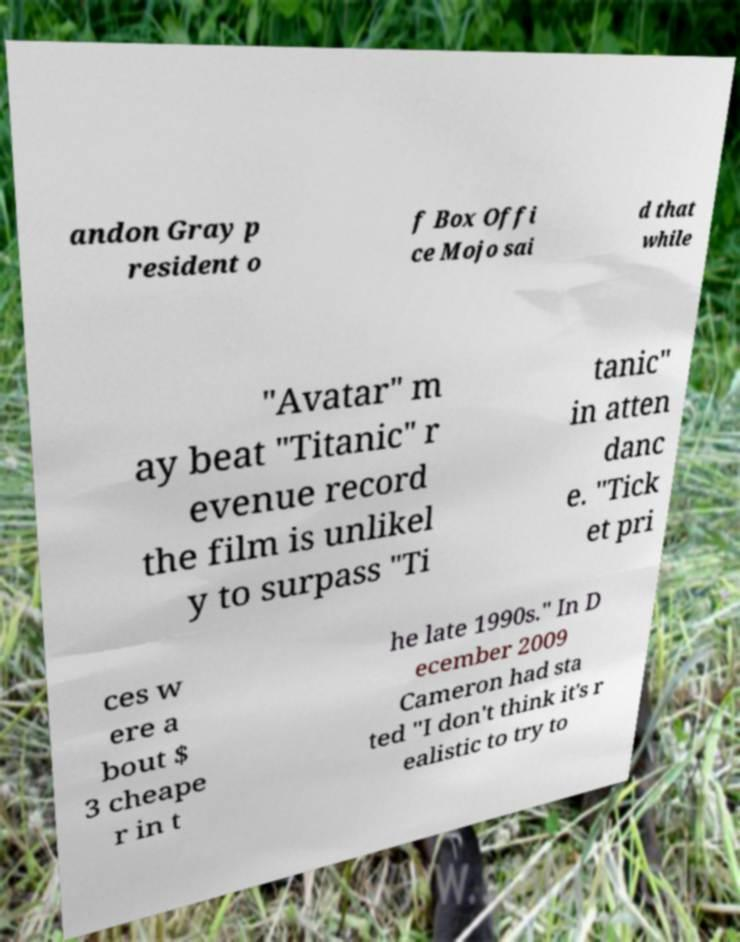For documentation purposes, I need the text within this image transcribed. Could you provide that? andon Gray p resident o f Box Offi ce Mojo sai d that while "Avatar" m ay beat "Titanic" r evenue record the film is unlikel y to surpass "Ti tanic" in atten danc e. "Tick et pri ces w ere a bout $ 3 cheape r in t he late 1990s." In D ecember 2009 Cameron had sta ted "I don't think it's r ealistic to try to 